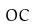Convert formula to latex. <formula><loc_0><loc_0><loc_500><loc_500>O C</formula> 